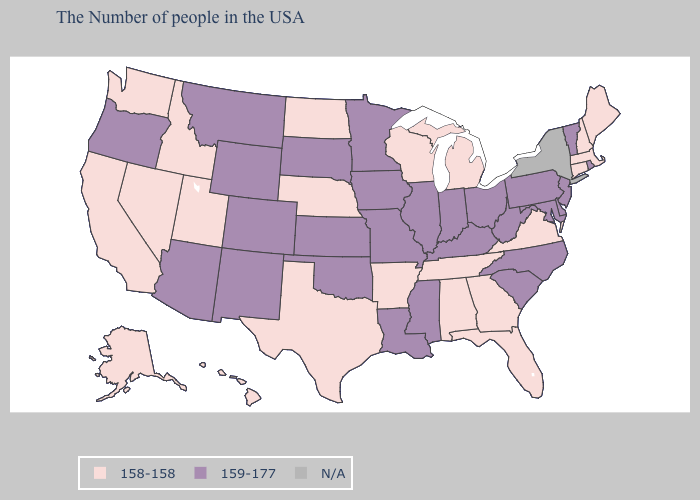Does the map have missing data?
Quick response, please. Yes. Name the states that have a value in the range 159-177?
Short answer required. Rhode Island, Vermont, New Jersey, Delaware, Maryland, Pennsylvania, North Carolina, South Carolina, West Virginia, Ohio, Kentucky, Indiana, Illinois, Mississippi, Louisiana, Missouri, Minnesota, Iowa, Kansas, Oklahoma, South Dakota, Wyoming, Colorado, New Mexico, Montana, Arizona, Oregon. What is the value of South Dakota?
Keep it brief. 159-177. What is the value of Illinois?
Write a very short answer. 159-177. What is the value of Rhode Island?
Answer briefly. 159-177. Name the states that have a value in the range 158-158?
Be succinct. Maine, Massachusetts, New Hampshire, Connecticut, Virginia, Florida, Georgia, Michigan, Alabama, Tennessee, Wisconsin, Arkansas, Nebraska, Texas, North Dakota, Utah, Idaho, Nevada, California, Washington, Alaska, Hawaii. What is the lowest value in states that border New Mexico?
Concise answer only. 158-158. What is the highest value in states that border Washington?
Give a very brief answer. 159-177. Among the states that border North Carolina , does Tennessee have the lowest value?
Write a very short answer. Yes. Is the legend a continuous bar?
Concise answer only. No. What is the lowest value in the USA?
Concise answer only. 158-158. Name the states that have a value in the range 159-177?
Write a very short answer. Rhode Island, Vermont, New Jersey, Delaware, Maryland, Pennsylvania, North Carolina, South Carolina, West Virginia, Ohio, Kentucky, Indiana, Illinois, Mississippi, Louisiana, Missouri, Minnesota, Iowa, Kansas, Oklahoma, South Dakota, Wyoming, Colorado, New Mexico, Montana, Arizona, Oregon. What is the value of Rhode Island?
Answer briefly. 159-177. Among the states that border Indiana , does Ohio have the highest value?
Be succinct. Yes. 